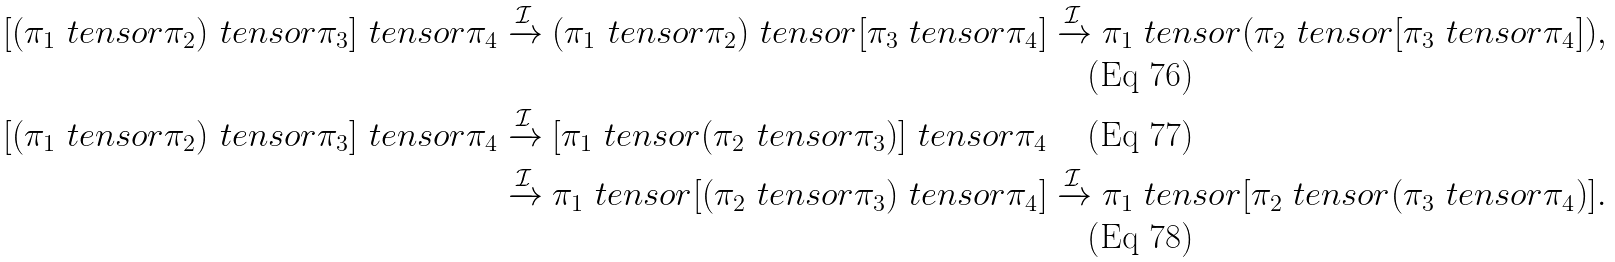Convert formula to latex. <formula><loc_0><loc_0><loc_500><loc_500>[ ( \pi _ { 1 } \ t e n s o r \pi _ { 2 } ) \ t e n s o r \pi _ { 3 } ] \ t e n s o r \pi _ { 4 } & \xrightarrow { \mathcal { I } } ( \pi _ { 1 } \ t e n s o r \pi _ { 2 } ) \ t e n s o r [ \pi _ { 3 } \ t e n s o r \pi _ { 4 } ] \xrightarrow { \mathcal { I } } \pi _ { 1 } \ t e n s o r ( \pi _ { 2 } \ t e n s o r [ \pi _ { 3 } \ t e n s o r \pi _ { 4 } ] ) , \\ [ ( \pi _ { 1 } \ t e n s o r \pi _ { 2 } ) \ t e n s o r \pi _ { 3 } ] \ t e n s o r \pi _ { 4 } & \xrightarrow { \mathcal { I } } [ \pi _ { 1 } \ t e n s o r ( \pi _ { 2 } \ t e n s o r \pi _ { 3 } ) ] \ t e n s o r \pi _ { 4 } \\ & \xrightarrow { \mathcal { I } } \pi _ { 1 } \ t e n s o r [ ( \pi _ { 2 } \ t e n s o r \pi _ { 3 } ) \ t e n s o r \pi _ { 4 } ] \xrightarrow { \mathcal { I } } \pi _ { 1 } \ t e n s o r [ \pi _ { 2 } \ t e n s o r ( \pi _ { 3 } \ t e n s o r \pi _ { 4 } ) ] .</formula> 